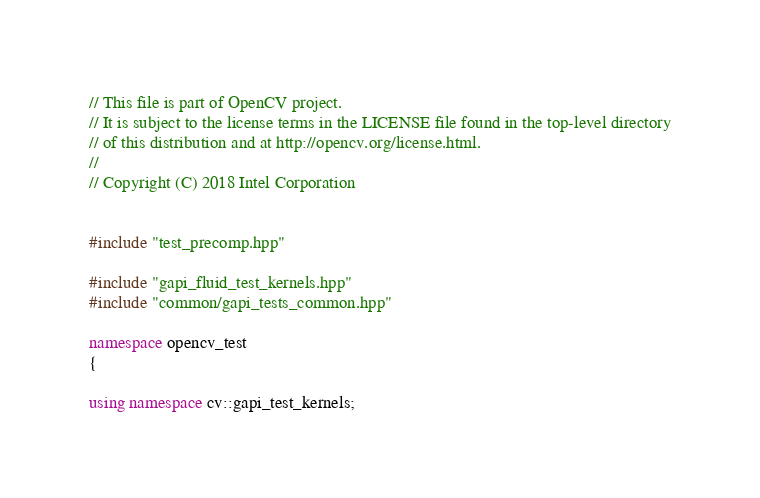Convert code to text. <code><loc_0><loc_0><loc_500><loc_500><_C++_>// This file is part of OpenCV project.
// It is subject to the license terms in the LICENSE file found in the top-level directory
// of this distribution and at http://opencv.org/license.html.
//
// Copyright (C) 2018 Intel Corporation


#include "test_precomp.hpp"

#include "gapi_fluid_test_kernels.hpp"
#include "common/gapi_tests_common.hpp"

namespace opencv_test
{

using namespace cv::gapi_test_kernels;
</code> 